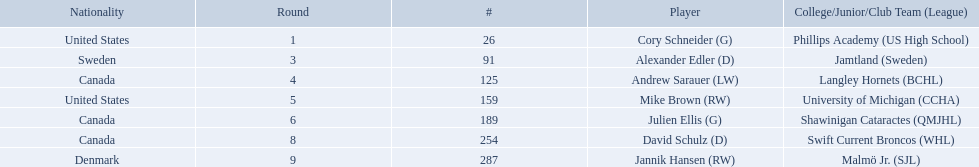What are the names of the colleges and jr leagues the players attended? Phillips Academy (US High School), Jamtland (Sweden), Langley Hornets (BCHL), University of Michigan (CCHA), Shawinigan Cataractes (QMJHL), Swift Current Broncos (WHL), Malmö Jr. (SJL). Which player played for the langley hornets? Andrew Sarauer (LW). 